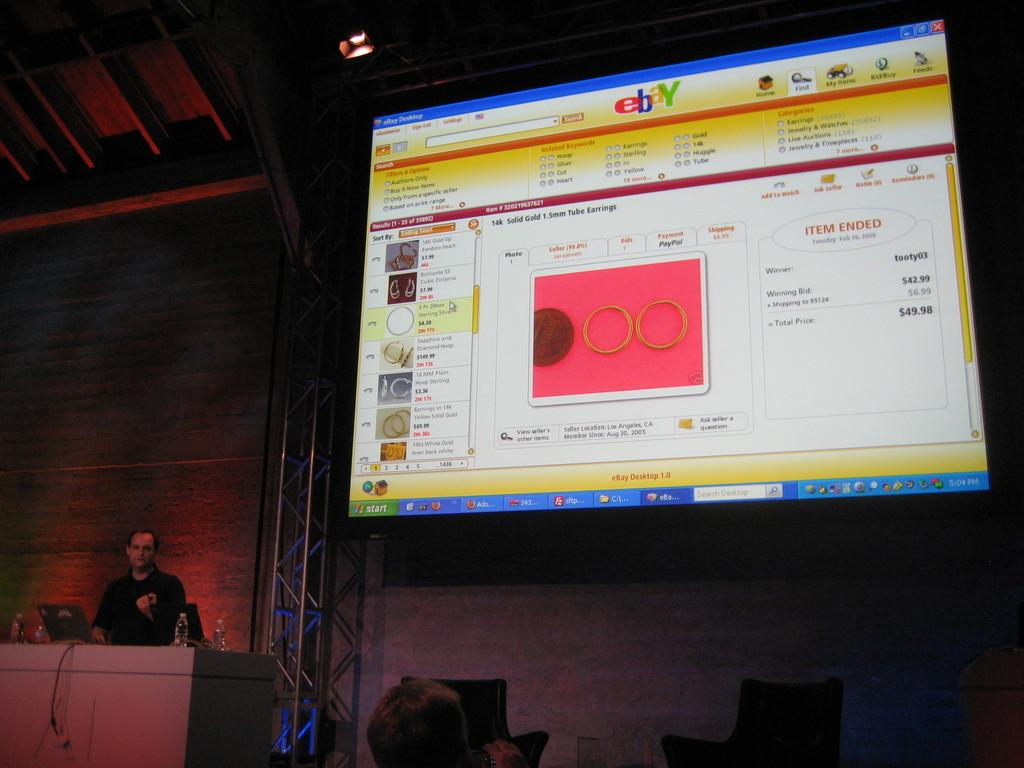<image>
Give a short and clear explanation of the subsequent image. A slideshow displaying an early screenshot of eBay. 